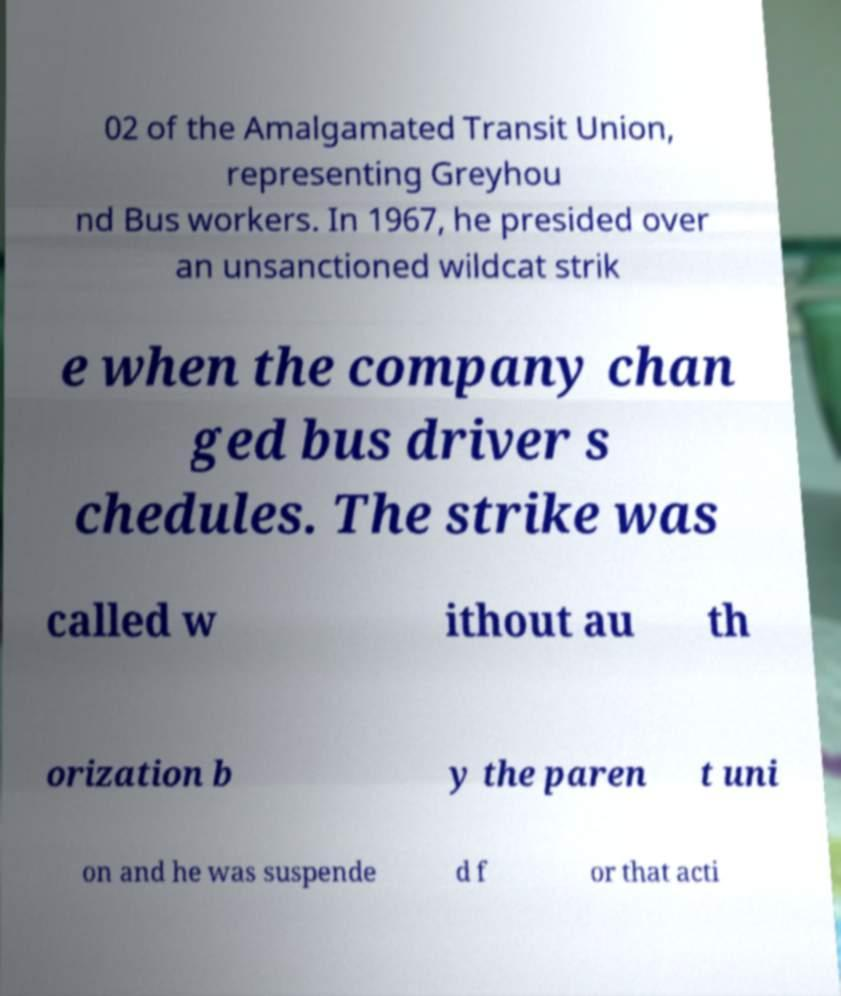Can you accurately transcribe the text from the provided image for me? 02 of the Amalgamated Transit Union, representing Greyhou nd Bus workers. In 1967, he presided over an unsanctioned wildcat strik e when the company chan ged bus driver s chedules. The strike was called w ithout au th orization b y the paren t uni on and he was suspende d f or that acti 